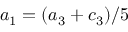<formula> <loc_0><loc_0><loc_500><loc_500>a _ { 1 } = ( a _ { 3 } + c _ { 3 } ) / 5</formula> 